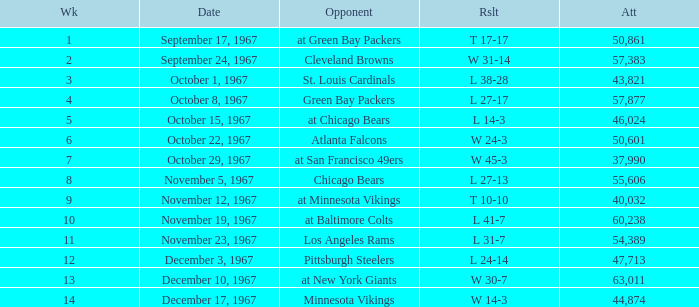Which Result has an Opponent of minnesota vikings? W 14-3. 